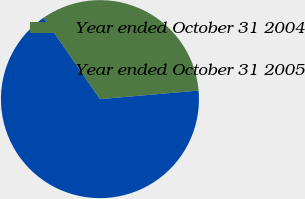<chart> <loc_0><loc_0><loc_500><loc_500><pie_chart><fcel>Year ended October 31 2004<fcel>Year ended October 31 2005<nl><fcel>33.25%<fcel>66.75%<nl></chart> 